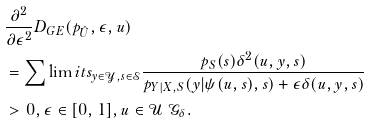Convert formula to latex. <formula><loc_0><loc_0><loc_500><loc_500>& \frac { \partial ^ { 2 } } { \partial \epsilon ^ { 2 } } D _ { G E } ( p _ { \hat { U } } , \epsilon , u ) \\ & = \sum \lim i t s _ { y \in \mathcal { Y } , s \in \mathcal { S } } \frac { p _ { S } ( s ) \delta ^ { 2 } ( u , y , s ) } { p _ { Y | X , S } ( y | \psi ( u , s ) , s ) + \epsilon \delta ( u , y , s ) } \\ & > 0 , \epsilon \in [ 0 , 1 ] , u \in \mathcal { U } \ \mathcal { G } _ { \delta } .</formula> 